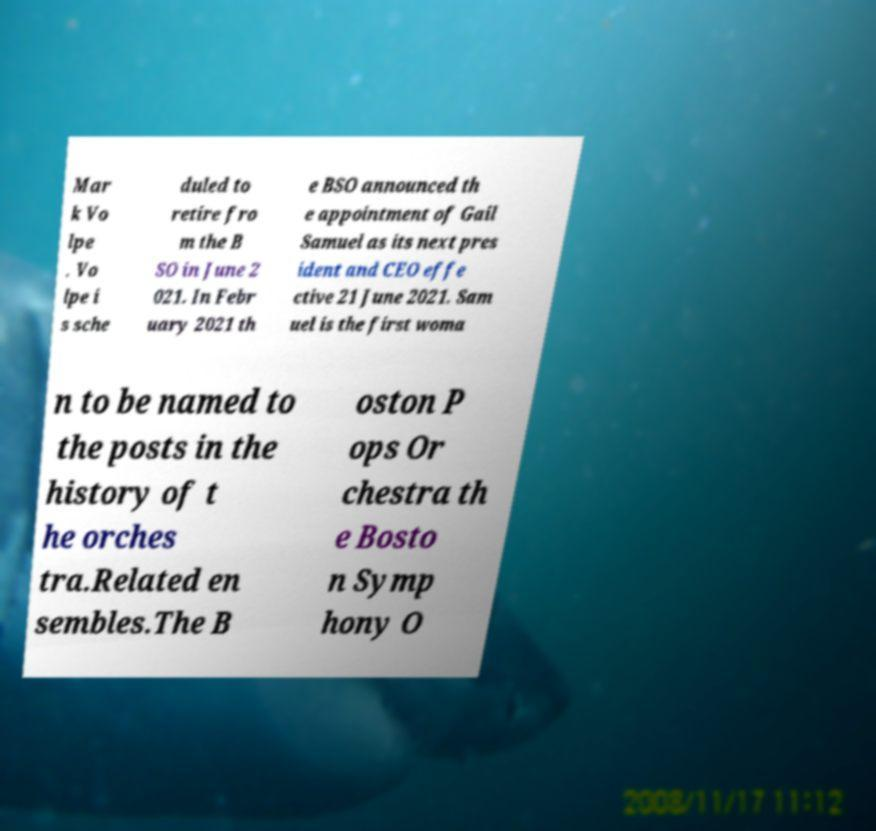Please read and relay the text visible in this image. What does it say? Mar k Vo lpe . Vo lpe i s sche duled to retire fro m the B SO in June 2 021. In Febr uary 2021 th e BSO announced th e appointment of Gail Samuel as its next pres ident and CEO effe ctive 21 June 2021. Sam uel is the first woma n to be named to the posts in the history of t he orches tra.Related en sembles.The B oston P ops Or chestra th e Bosto n Symp hony O 